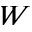Convert formula to latex. <formula><loc_0><loc_0><loc_500><loc_500>W</formula> 